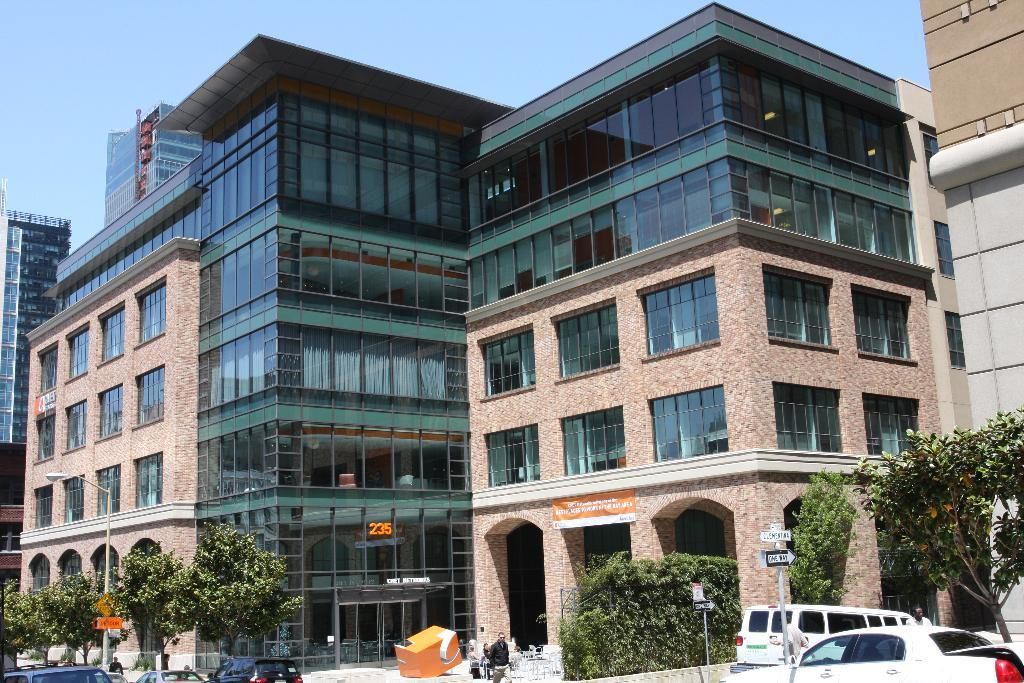What can be seen in the foreground of the image? In the foreground of the image, there are people, trees, vehicles, and poles. What is visible in the background of the image? In the background of the image, there are buildings and the sky. What arithmetic problem is being solved by the people in the image? There is no indication in the image that the people are solving an arithmetic problem. What type of writing can be seen on the poles in the image? There is no writing visible on the poles in the image. 